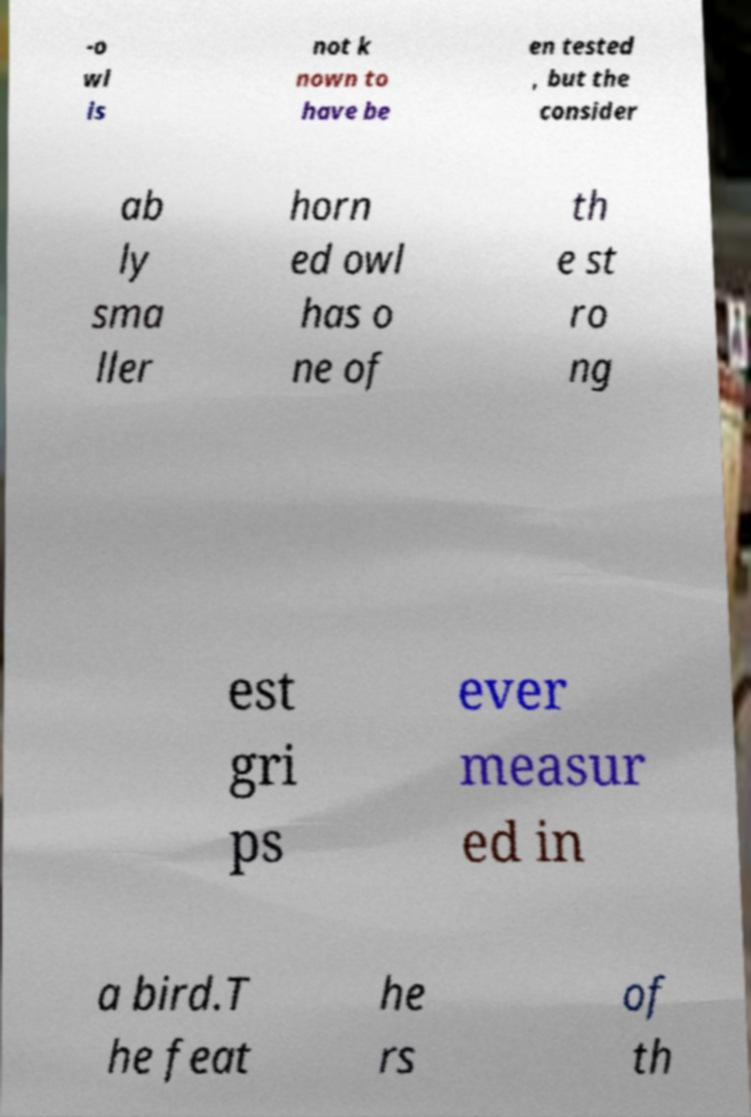There's text embedded in this image that I need extracted. Can you transcribe it verbatim? -o wl is not k nown to have be en tested , but the consider ab ly sma ller horn ed owl has o ne of th e st ro ng est gri ps ever measur ed in a bird.T he feat he rs of th 